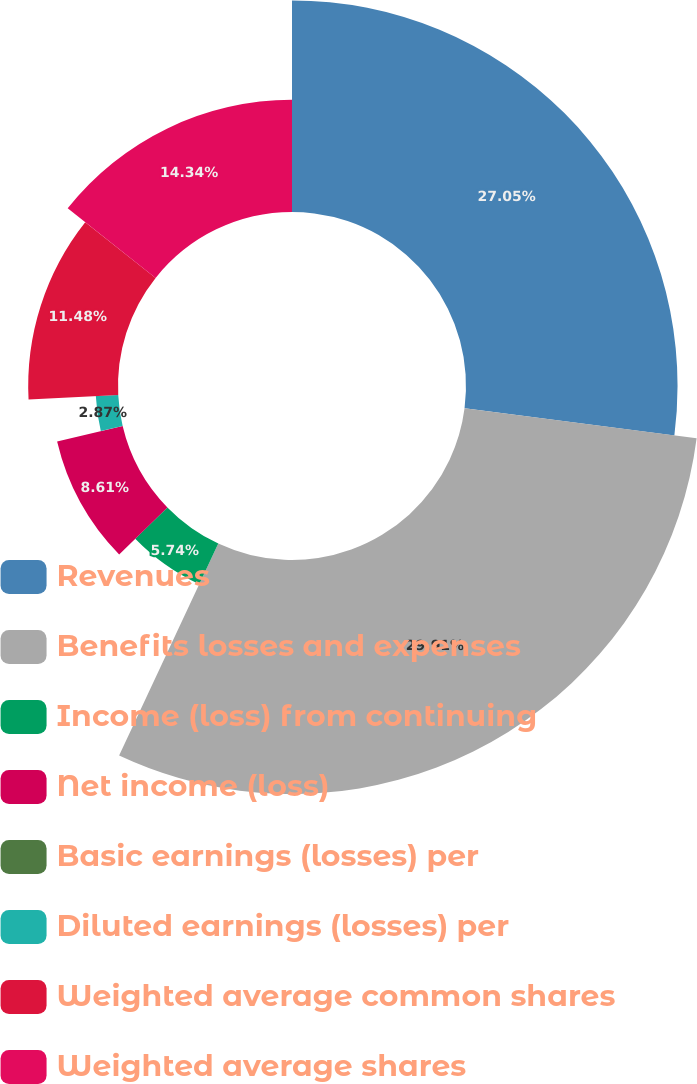Convert chart. <chart><loc_0><loc_0><loc_500><loc_500><pie_chart><fcel>Revenues<fcel>Benefits losses and expenses<fcel>Income (loss) from continuing<fcel>Net income (loss)<fcel>Basic earnings (losses) per<fcel>Diluted earnings (losses) per<fcel>Weighted average common shares<fcel>Weighted average shares<nl><fcel>27.05%<fcel>29.92%<fcel>5.74%<fcel>8.61%<fcel>0.0%<fcel>2.87%<fcel>11.48%<fcel>14.34%<nl></chart> 